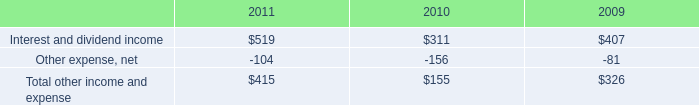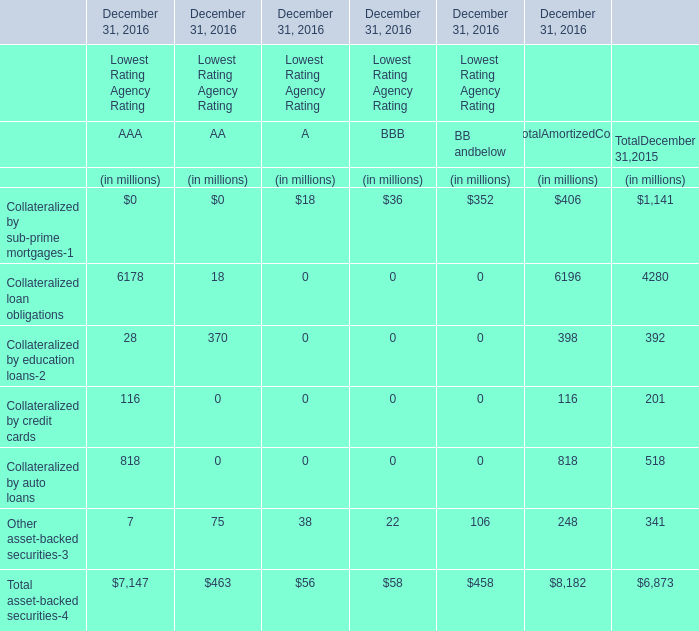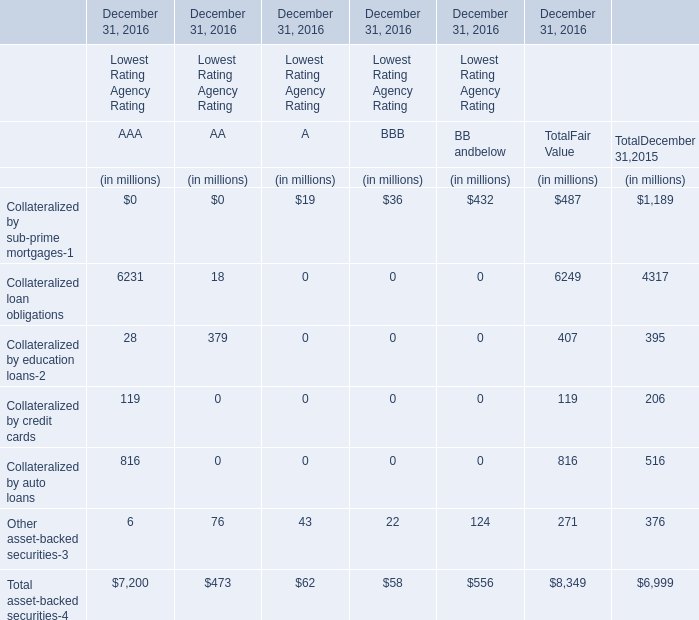What's the total value of all AA of Lowest Rating Agency Rating that are in the range of 0 and 100 in 2016 for December 31, 2016 ? (in million) 
Computations: (18 + 75)
Answer: 93.0. 